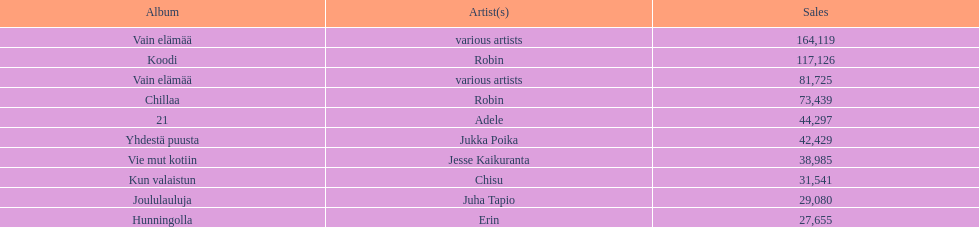Does adele or chisu have the highest number of sales? Adele. 